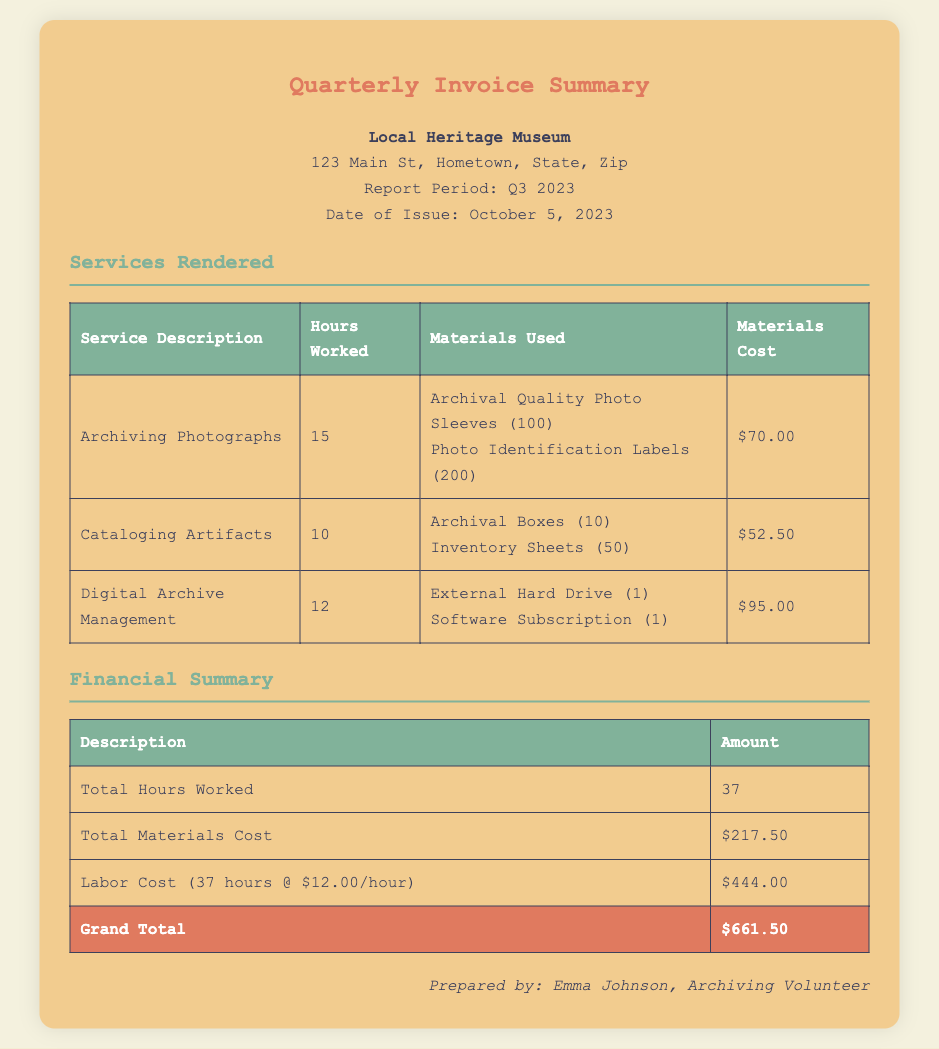What is the total hours worked? The total hours worked is a summary of all hours logged for each service rendered in the document, which is 15 + 10 + 12.
Answer: 37 What is the date of issue for the report? The date of issue is explicitly stated in the document, which is October 5, 2023.
Answer: October 5, 2023 How much did the materials for archiving photographs cost? The materials cost for archiving photographs is listed in the table under the "Materials Cost" column for that service, which is $70.00.
Answer: $70.00 Who prepared the document? The preparer of the document is indicated at the end of the report, which is Emma Johnson, Archiving Volunteer.
Answer: Emma Johnson, Archiving Volunteer What is the grand total amount? The grand total is presented in the financial summary section, indicating the final amount due for the services rendered, which is $661.50.
Answer: $661.50 How many archival boxes were used in the cataloging artifacts service? The number of archival boxes used is specified in the table under "Materials Used" for cataloging artifacts, which is 10.
Answer: 10 What is the labor cost per hour? The labor cost per hour is mentioned in the financial summary as $12.00 per hour.
Answer: $12.00 What materials were used for digital archive management? The materials used for digital archive management are detailed in the table under "Materials Used," which includes an external hard drive and software subscription.
Answer: External Hard Drive (1), Software Subscription (1) 